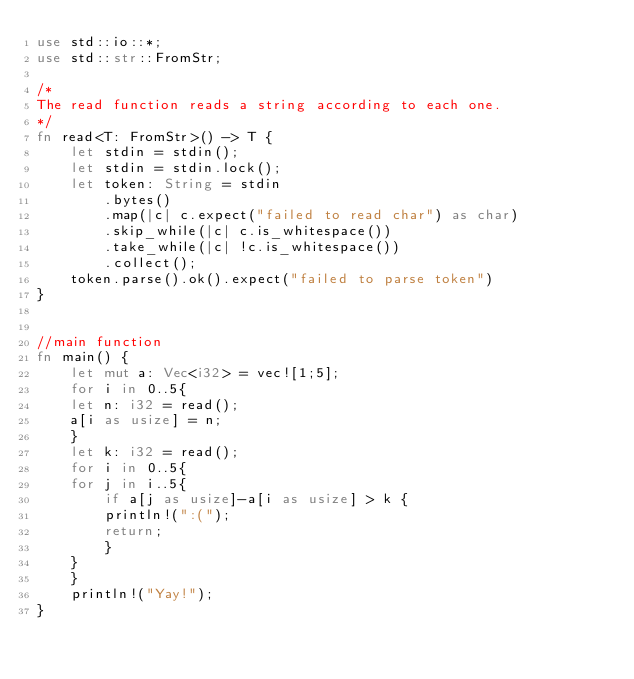<code> <loc_0><loc_0><loc_500><loc_500><_Rust_>use std::io::*;
use std::str::FromStr;
 
/* 
The read function reads a string according to each one. 
*/
fn read<T: FromStr>() -> T {
    let stdin = stdin();
    let stdin = stdin.lock();
    let token: String = stdin
        .bytes()
        .map(|c| c.expect("failed to read char") as char) 
        .skip_while(|c| c.is_whitespace())
        .take_while(|c| !c.is_whitespace())
        .collect();
    token.parse().ok().expect("failed to parse token")
}


//main function
fn main() {
    let mut a: Vec<i32> = vec![1;5];
    for i in 0..5{
	let n: i32 = read();
	a[i as usize] = n;
    }
    let k: i32 = read();
    for i in 0..5{
	for j in i..5{
	    if a[j as usize]-a[i as usize] > k {
		println!(":(");
		return;
	    }
	}
    }
    println!("Yay!");
}
</code> 